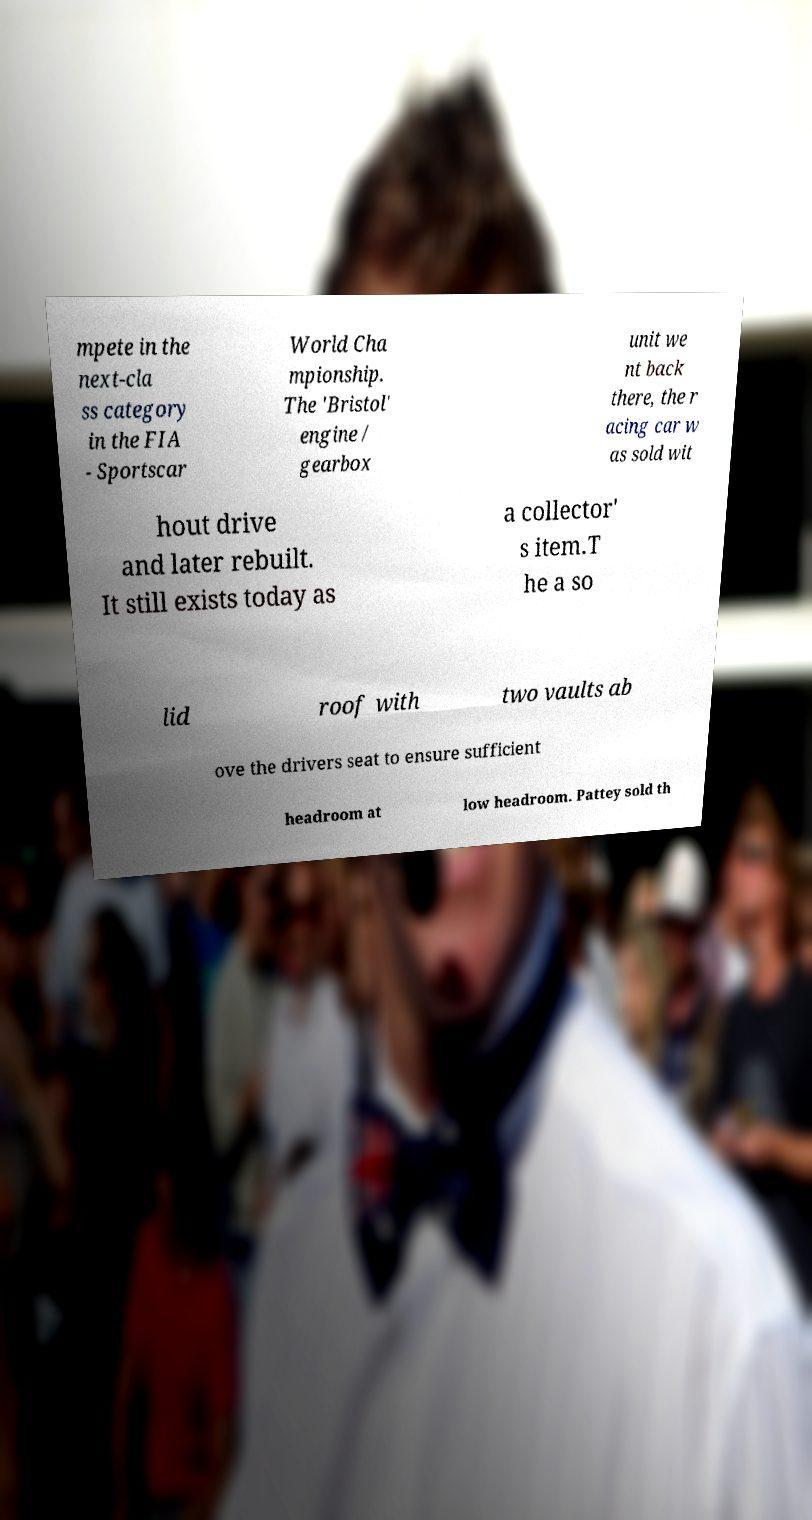Please read and relay the text visible in this image. What does it say? mpete in the next-cla ss category in the FIA - Sportscar World Cha mpionship. The 'Bristol' engine / gearbox unit we nt back there, the r acing car w as sold wit hout drive and later rebuilt. It still exists today as a collector' s item.T he a so lid roof with two vaults ab ove the drivers seat to ensure sufficient headroom at low headroom. Pattey sold th 